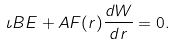Convert formula to latex. <formula><loc_0><loc_0><loc_500><loc_500>\iota B E + A F ( r ) \frac { d W } { d r } = 0 .</formula> 